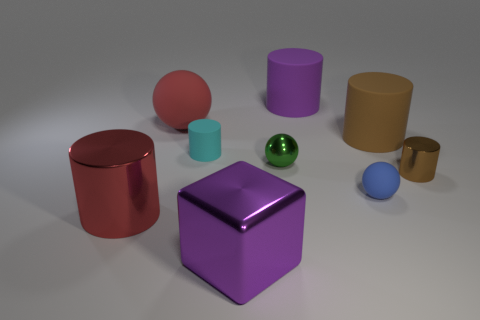Subtract all purple cylinders. How many cylinders are left? 4 Subtract all brown rubber cylinders. How many cylinders are left? 4 Subtract all green cylinders. Subtract all red spheres. How many cylinders are left? 5 Add 1 large purple matte cylinders. How many objects exist? 10 Subtract all cylinders. How many objects are left? 4 Add 1 small cyan matte things. How many small cyan matte things are left? 2 Add 2 tiny brown metal things. How many tiny brown metal things exist? 3 Subtract 0 red blocks. How many objects are left? 9 Subtract all purple matte cubes. Subtract all big metal cubes. How many objects are left? 8 